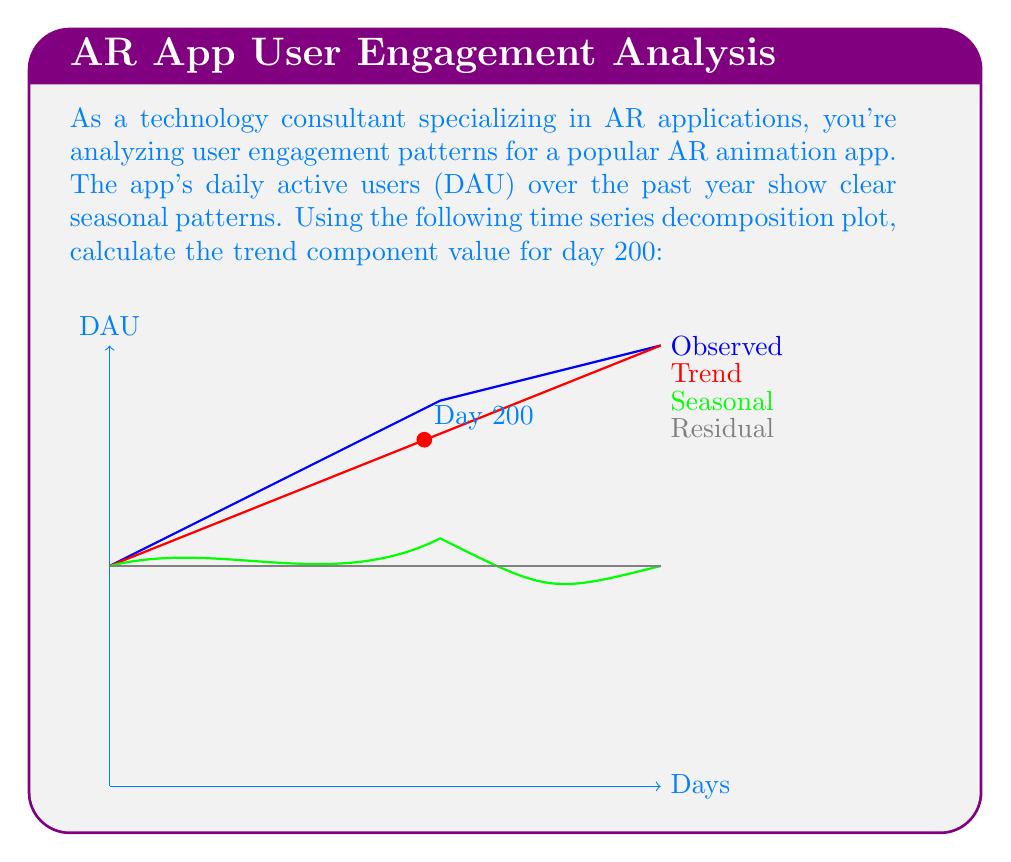What is the answer to this math problem? To solve this problem, we need to understand the components of time series decomposition and how to interpret the graph:

1. The time series is decomposed into three components: Trend, Seasonal, and Residual.

2. The relationship between these components is typically additive:
   $$ \text{Observed} = \text{Trend} + \text{Seasonal} + \text{Residual} $$

3. In the graph, we can see four lines representing each component:
   - Blue: Observed data
   - Red: Trend component
   - Green: Seasonal component
   - Gray: Residual component (appears flat at zero in this case)

4. We need to find the trend component value at day 200.

5. Looking at the red line (Trend) in the graph, we can see that it passes through the point (200, 1600).

Therefore, the trend component value for day 200 is 1600 DAU.

This trend line represents the long-term progression of user engagement, smoothing out seasonal fluctuations and random variations. For AR applications, understanding this trend is crucial for predicting future user behavior and planning content updates or feature releases.
Answer: 1600 DAU 